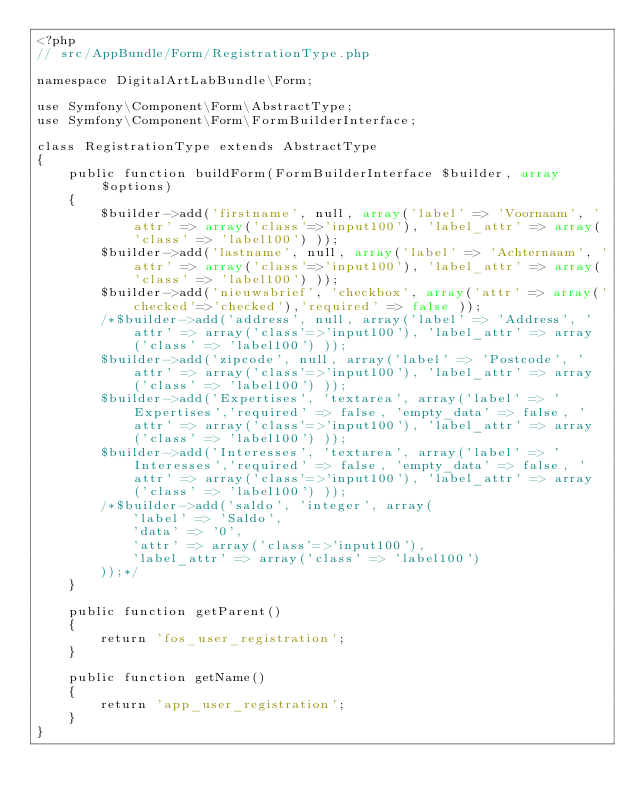<code> <loc_0><loc_0><loc_500><loc_500><_PHP_><?php
// src/AppBundle/Form/RegistrationType.php

namespace DigitalArtLabBundle\Form;

use Symfony\Component\Form\AbstractType;
use Symfony\Component\Form\FormBuilderInterface;

class RegistrationType extends AbstractType
{
    public function buildForm(FormBuilderInterface $builder, array $options)
    {
        $builder->add('firstname', null, array('label' => 'Voornaam', 'attr' => array('class'=>'input100'), 'label_attr' => array('class' => 'label100') ));
        $builder->add('lastname', null, array('label' => 'Achternaam', 'attr' => array('class'=>'input100'), 'label_attr' => array('class' => 'label100') ));
        $builder->add('nieuwsbrief', 'checkbox', array('attr' => array('checked'=>'checked'),'required' => false ));
        /*$builder->add('address', null, array('label' => 'Address', 'attr' => array('class'=>'input100'), 'label_attr' => array('class' => 'label100') ));
        $builder->add('zipcode', null, array('label' => 'Postcode', 'attr' => array('class'=>'input100'), 'label_attr' => array('class' => 'label100') ));
        $builder->add('Expertises', 'textarea', array('label' => 'Expertises','required' => false, 'empty_data' => false, 'attr' => array('class'=>'input100'), 'label_attr' => array('class' => 'label100') ));
        $builder->add('Interesses', 'textarea', array('label' => 'Interesses','required' => false, 'empty_data' => false, 'attr' => array('class'=>'input100'), 'label_attr' => array('class' => 'label100') ));
        /*$builder->add('saldo', 'integer', array(
            'label' => 'Saldo',
            'data' => '0',
            'attr' => array('class'=>'input100'),
            'label_attr' => array('class' => 'label100')
        ));*/
    }

    public function getParent()
    {
        return 'fos_user_registration';
    }

    public function getName()
    {
        return 'app_user_registration';
    }
}</code> 